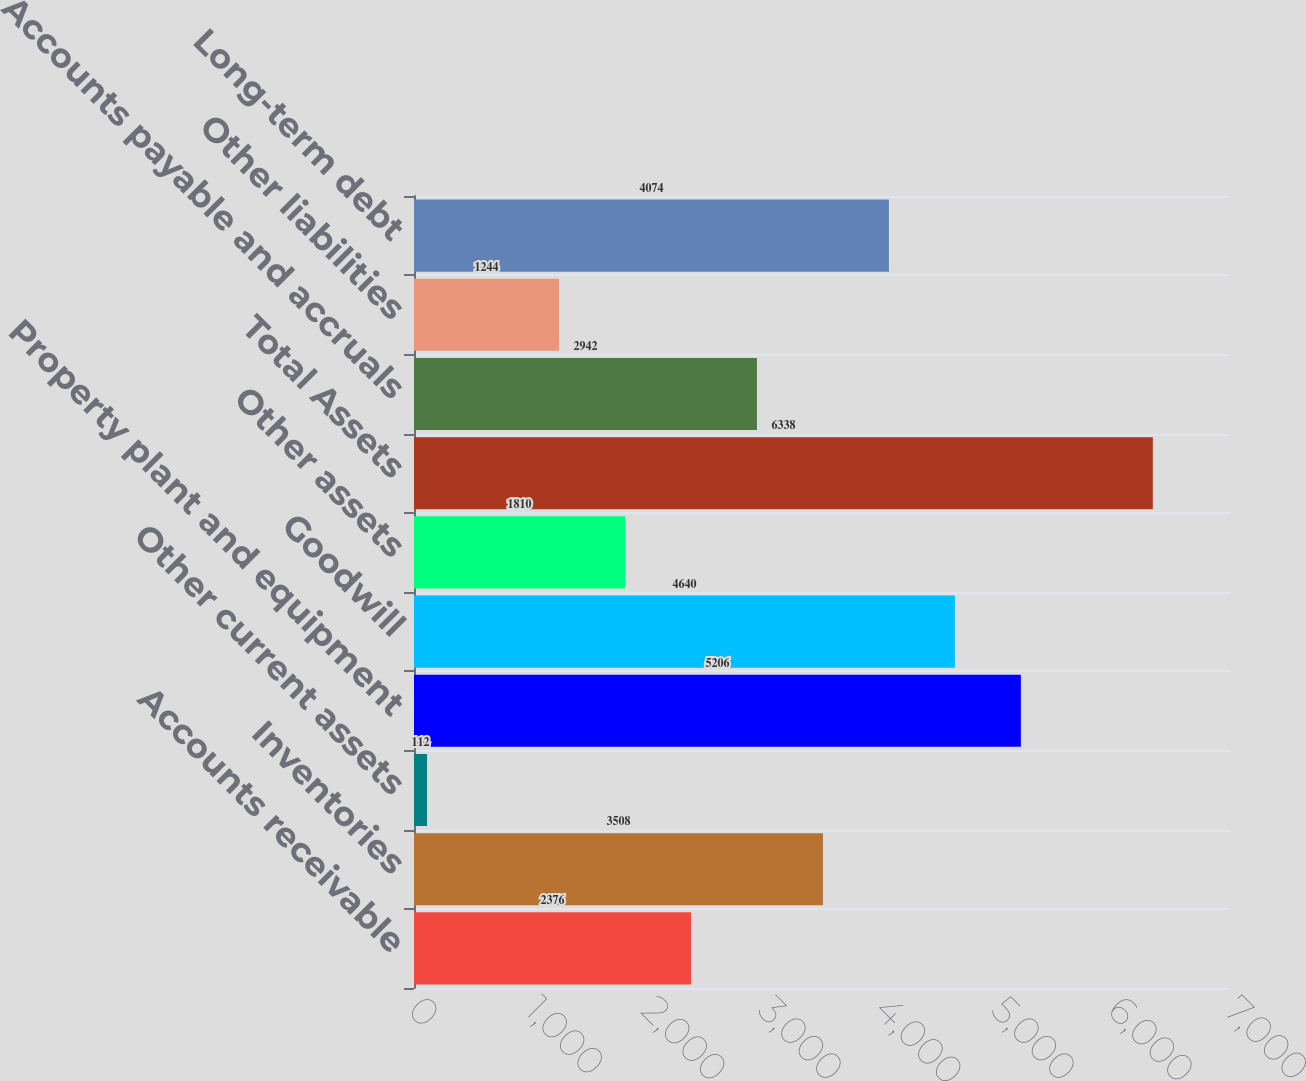<chart> <loc_0><loc_0><loc_500><loc_500><bar_chart><fcel>Accounts receivable<fcel>Inventories<fcel>Other current assets<fcel>Property plant and equipment<fcel>Goodwill<fcel>Other assets<fcel>Total Assets<fcel>Accounts payable and accruals<fcel>Other liabilities<fcel>Long-term debt<nl><fcel>2376<fcel>3508<fcel>112<fcel>5206<fcel>4640<fcel>1810<fcel>6338<fcel>2942<fcel>1244<fcel>4074<nl></chart> 